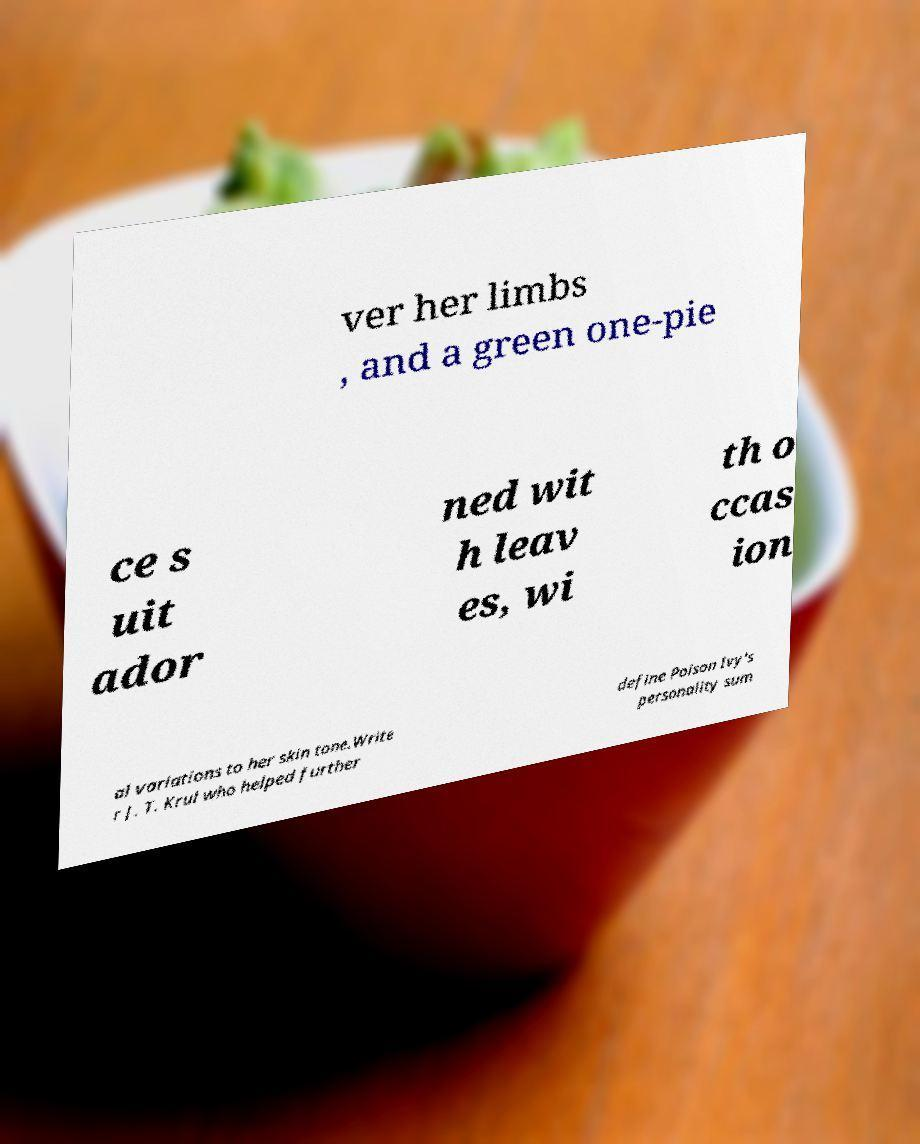For documentation purposes, I need the text within this image transcribed. Could you provide that? ver her limbs , and a green one-pie ce s uit ador ned wit h leav es, wi th o ccas ion al variations to her skin tone.Write r J. T. Krul who helped further define Poison Ivy's personality sum 